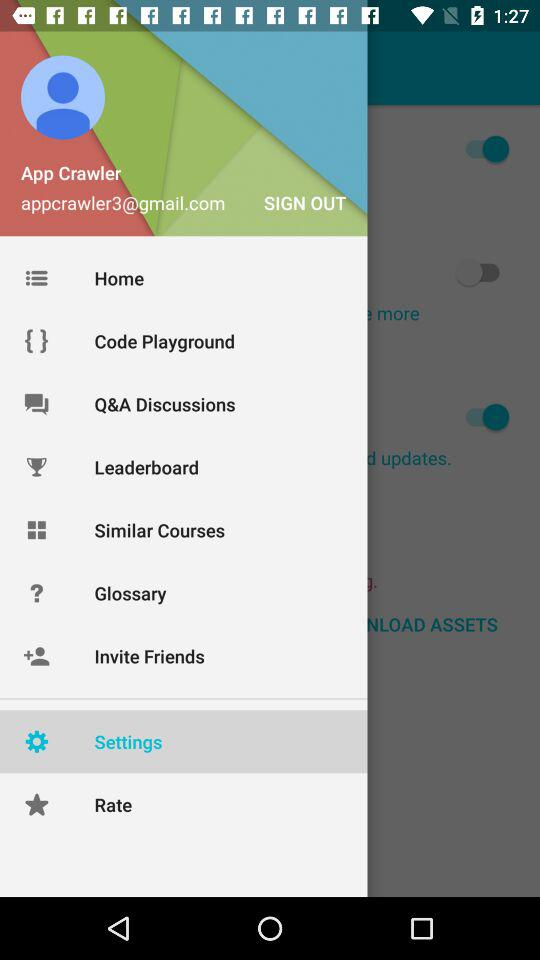What is the email address? The email address is appcrawler3@gmail.com. 